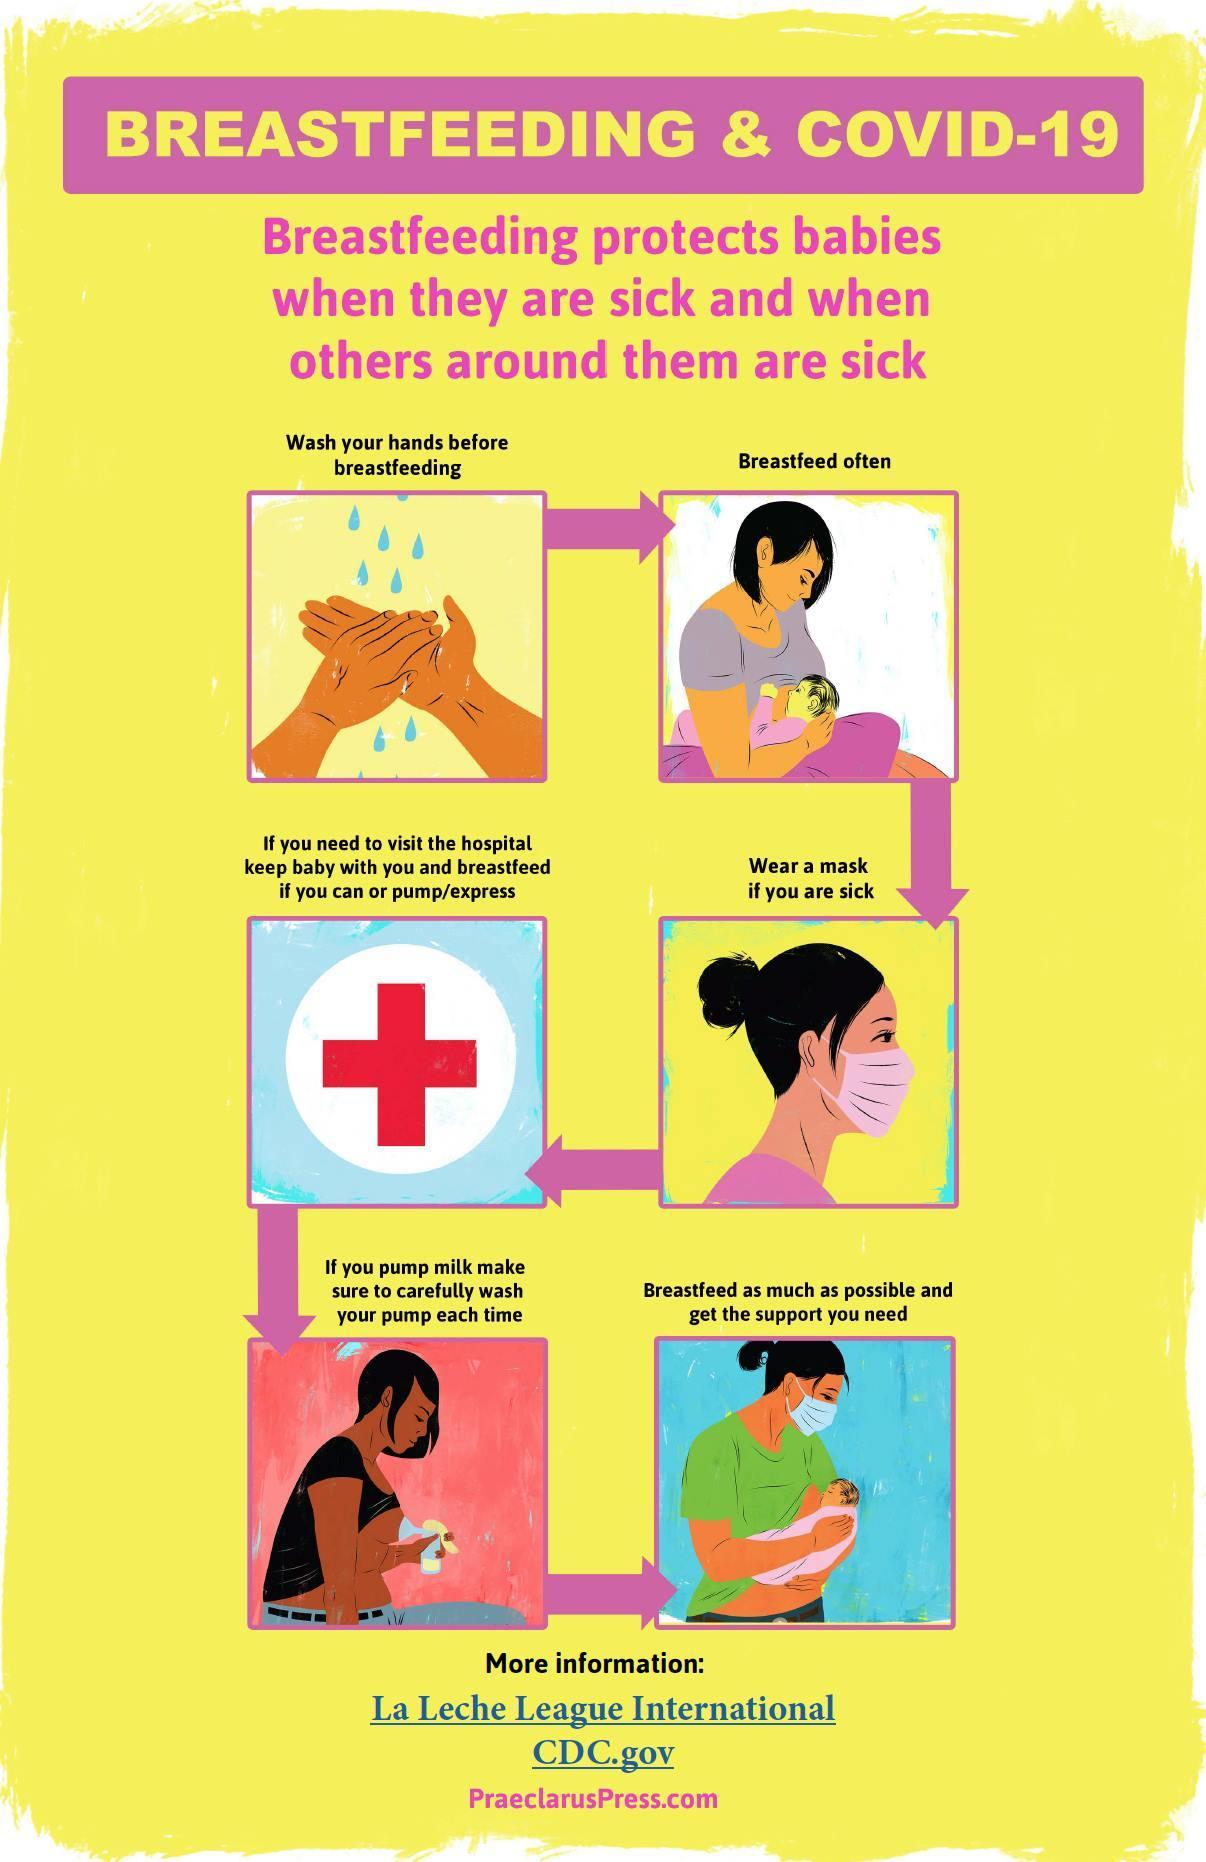How many times breastfeeding of the babies are shown in this infographic image?
Answer the question with a short phrase. 2 How many people wore masks in this infographic image? 2 